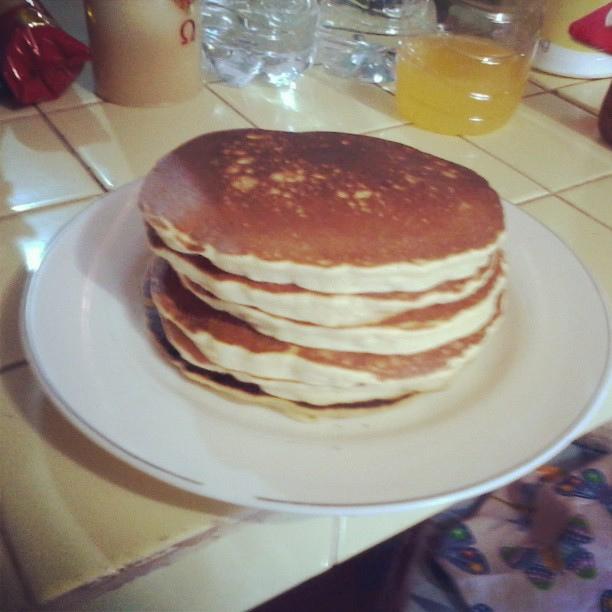What material is the table made from?
Answer briefly. Tile. Is this meal vegan?
Write a very short answer. No. What's on the plate?
Short answer required. Pancakes. How many pancakes are on the plate?
Give a very brief answer. 6. What is on the white plate?
Keep it brief. Pancakes. Is that pineapple juice in the jar?
Be succinct. Yes. 